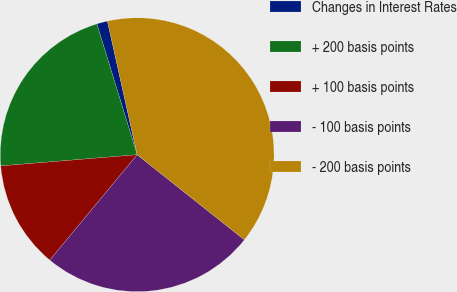Convert chart to OTSL. <chart><loc_0><loc_0><loc_500><loc_500><pie_chart><fcel>Changes in Interest Rates<fcel>+ 200 basis points<fcel>+ 100 basis points<fcel>- 100 basis points<fcel>- 200 basis points<nl><fcel>1.27%<fcel>21.55%<fcel>12.68%<fcel>25.34%<fcel>39.16%<nl></chart> 